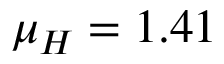<formula> <loc_0><loc_0><loc_500><loc_500>\mu _ { H } = 1 . 4 1</formula> 